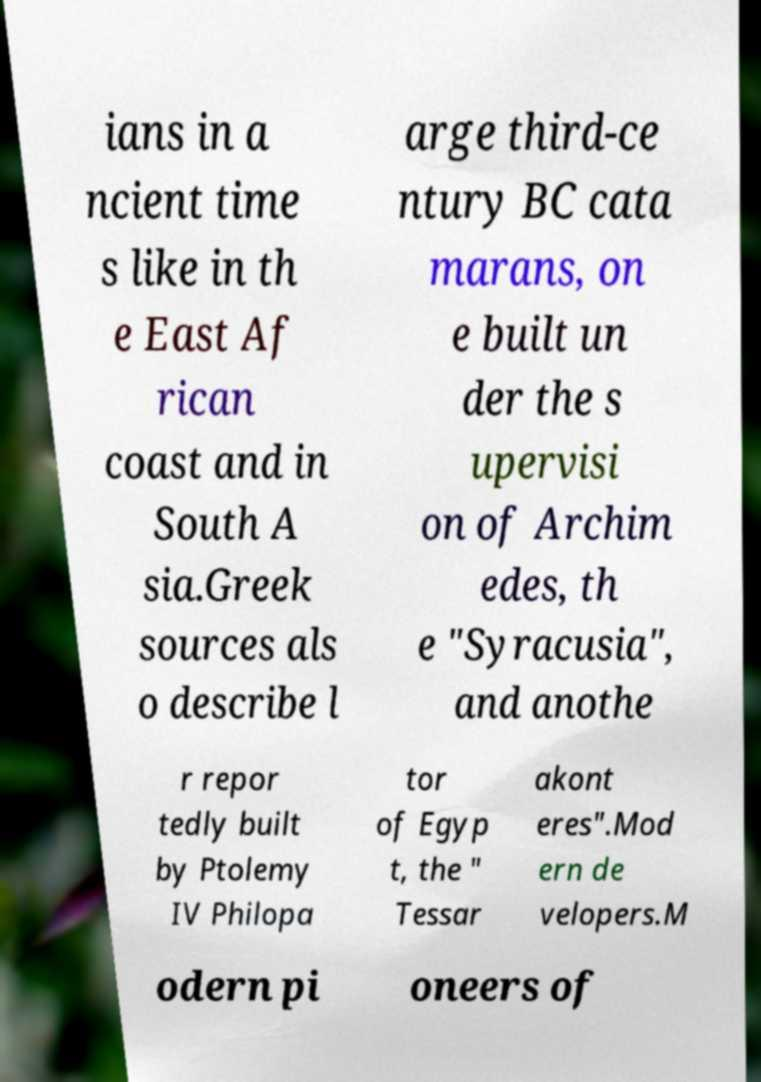Can you read and provide the text displayed in the image?This photo seems to have some interesting text. Can you extract and type it out for me? ians in a ncient time s like in th e East Af rican coast and in South A sia.Greek sources als o describe l arge third-ce ntury BC cata marans, on e built un der the s upervisi on of Archim edes, th e "Syracusia", and anothe r repor tedly built by Ptolemy IV Philopa tor of Egyp t, the " Tessar akont eres".Mod ern de velopers.M odern pi oneers of 